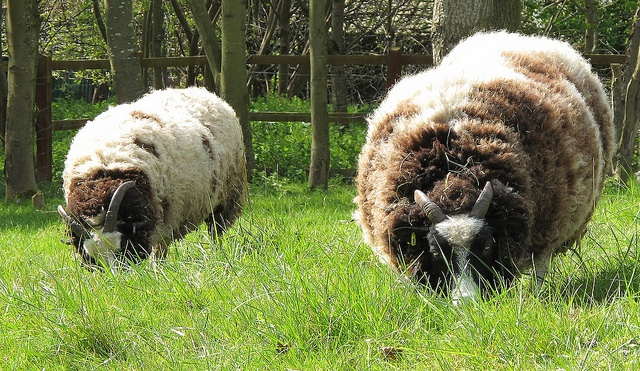Describe the objects in this image and their specific colors. I can see sheep in black, white, and gray tones and sheep in black, ivory, and gray tones in this image. 